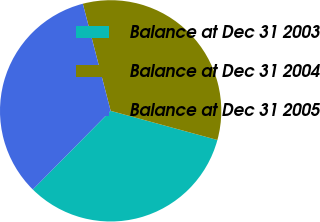Convert chart. <chart><loc_0><loc_0><loc_500><loc_500><pie_chart><fcel>Balance at Dec 31 2003<fcel>Balance at Dec 31 2004<fcel>Balance at Dec 31 2005<nl><fcel>33.17%<fcel>33.29%<fcel>33.54%<nl></chart> 